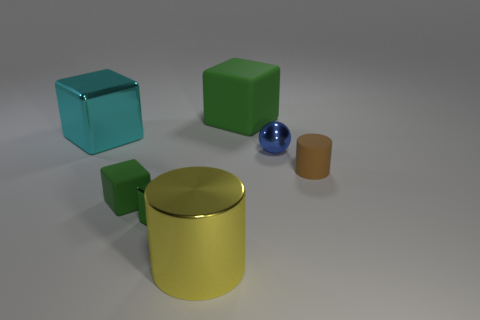Subtract all green blocks. How many were subtracted if there are1green blocks left? 2 Subtract all brown balls. How many green blocks are left? 3 Subtract all red cubes. Subtract all brown cylinders. How many cubes are left? 4 Add 2 cylinders. How many objects exist? 9 Subtract all spheres. How many objects are left? 6 Add 7 yellow things. How many yellow things exist? 8 Subtract 0 yellow cubes. How many objects are left? 7 Subtract all small green spheres. Subtract all green blocks. How many objects are left? 4 Add 2 small objects. How many small objects are left? 6 